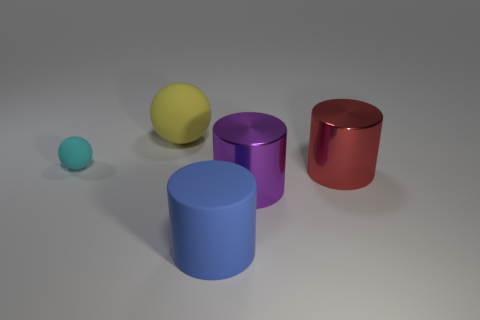Are the object that is right of the big purple shiny object and the big cylinder that is in front of the big purple cylinder made of the same material?
Offer a very short reply. No. What is the size of the matte ball that is in front of the big matte object behind the purple cylinder?
Your response must be concise. Small. What size is the cyan rubber sphere?
Provide a short and direct response. Small. How many other things are there of the same material as the cyan ball?
Ensure brevity in your answer.  2. Are there any large matte spheres?
Provide a succinct answer. Yes. Is the big object left of the big blue object made of the same material as the tiny cyan object?
Offer a very short reply. Yes. What is the material of the big blue thing that is the same shape as the red thing?
Offer a terse response. Rubber. Is the number of red metallic cylinders less than the number of rubber balls?
Ensure brevity in your answer.  Yes. There is a large matte thing that is behind the blue matte cylinder; is it the same color as the small object?
Give a very brief answer. No. What is the color of the big object that is made of the same material as the large blue cylinder?
Provide a short and direct response. Yellow. 